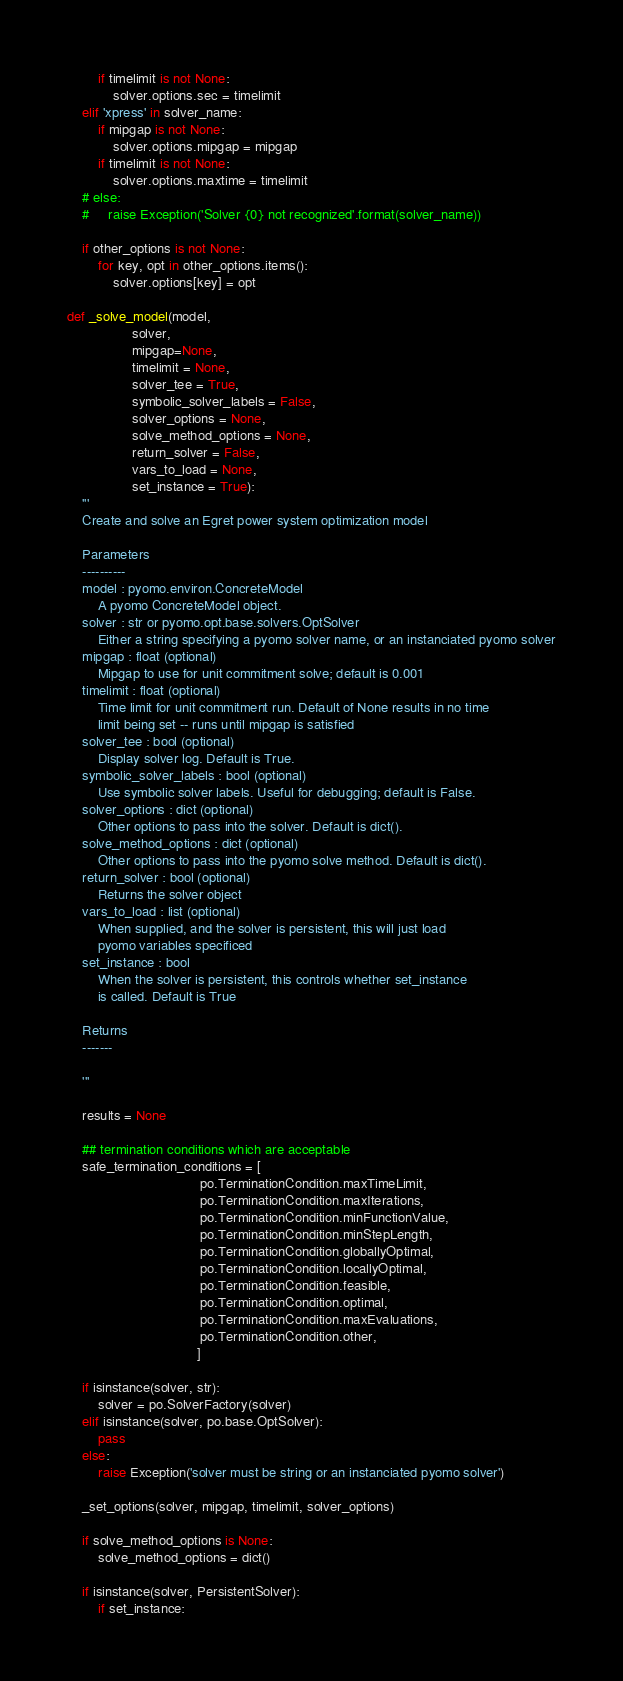Convert code to text. <code><loc_0><loc_0><loc_500><loc_500><_Python_>        if timelimit is not None:
            solver.options.sec = timelimit
    elif 'xpress' in solver_name:
        if mipgap is not None:
            solver.options.mipgap = mipgap
        if timelimit is not None:
            solver.options.maxtime = timelimit
    # else:
    #     raise Exception('Solver {0} not recognized'.format(solver_name))

    if other_options is not None:
        for key, opt in other_options.items():
            solver.options[key] = opt

def _solve_model(model,
                 solver,
                 mipgap=None,
                 timelimit = None,
                 solver_tee = True,
                 symbolic_solver_labels = False,
                 solver_options = None,
                 solve_method_options = None,
                 return_solver = False,
                 vars_to_load = None,
                 set_instance = True):
    '''
    Create and solve an Egret power system optimization model

    Parameters
    ----------
    model : pyomo.environ.ConcreteModel
        A pyomo ConcreteModel object.
    solver : str or pyomo.opt.base.solvers.OptSolver
        Either a string specifying a pyomo solver name, or an instanciated pyomo solver
    mipgap : float (optional)
        Mipgap to use for unit commitment solve; default is 0.001
    timelimit : float (optional)
        Time limit for unit commitment run. Default of None results in no time
        limit being set -- runs until mipgap is satisfied
    solver_tee : bool (optional)
        Display solver log. Default is True.
    symbolic_solver_labels : bool (optional)
        Use symbolic solver labels. Useful for debugging; default is False.
    solver_options : dict (optional)
        Other options to pass into the solver. Default is dict().
    solve_method_options : dict (optional)
        Other options to pass into the pyomo solve method. Default is dict().
    return_solver : bool (optional)
        Returns the solver object
    vars_to_load : list (optional)
        When supplied, and the solver is persistent, this will just load
        pyomo variables specificed
    set_instance : bool
        When the solver is persistent, this controls whether set_instance
        is called. Default is True

    Returns
    -------

    '''

    results = None

    ## termination conditions which are acceptable
    safe_termination_conditions = [
                                   po.TerminationCondition.maxTimeLimit,
                                   po.TerminationCondition.maxIterations,
                                   po.TerminationCondition.minFunctionValue,
                                   po.TerminationCondition.minStepLength,
                                   po.TerminationCondition.globallyOptimal,
                                   po.TerminationCondition.locallyOptimal,
                                   po.TerminationCondition.feasible,
                                   po.TerminationCondition.optimal,
                                   po.TerminationCondition.maxEvaluations,
                                   po.TerminationCondition.other,
                                  ]

    if isinstance(solver, str):
        solver = po.SolverFactory(solver)
    elif isinstance(solver, po.base.OptSolver):
        pass
    else:
        raise Exception('solver must be string or an instanciated pyomo solver')

    _set_options(solver, mipgap, timelimit, solver_options)

    if solve_method_options is None:
        solve_method_options = dict()

    if isinstance(solver, PersistentSolver):
        if set_instance:</code> 